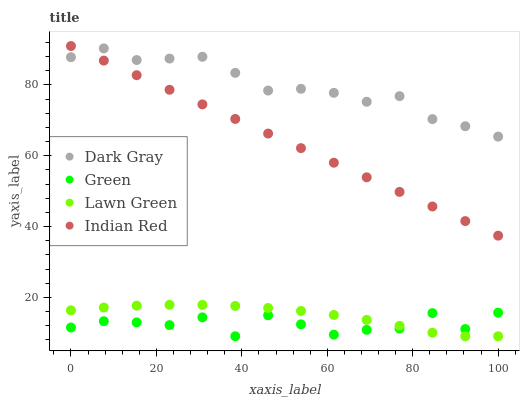Does Green have the minimum area under the curve?
Answer yes or no. Yes. Does Dark Gray have the maximum area under the curve?
Answer yes or no. Yes. Does Lawn Green have the minimum area under the curve?
Answer yes or no. No. Does Lawn Green have the maximum area under the curve?
Answer yes or no. No. Is Indian Red the smoothest?
Answer yes or no. Yes. Is Green the roughest?
Answer yes or no. Yes. Is Lawn Green the smoothest?
Answer yes or no. No. Is Lawn Green the roughest?
Answer yes or no. No. Does Lawn Green have the lowest value?
Answer yes or no. Yes. Does Indian Red have the lowest value?
Answer yes or no. No. Does Indian Red have the highest value?
Answer yes or no. Yes. Does Lawn Green have the highest value?
Answer yes or no. No. Is Green less than Indian Red?
Answer yes or no. Yes. Is Indian Red greater than Green?
Answer yes or no. Yes. Does Green intersect Lawn Green?
Answer yes or no. Yes. Is Green less than Lawn Green?
Answer yes or no. No. Is Green greater than Lawn Green?
Answer yes or no. No. Does Green intersect Indian Red?
Answer yes or no. No. 